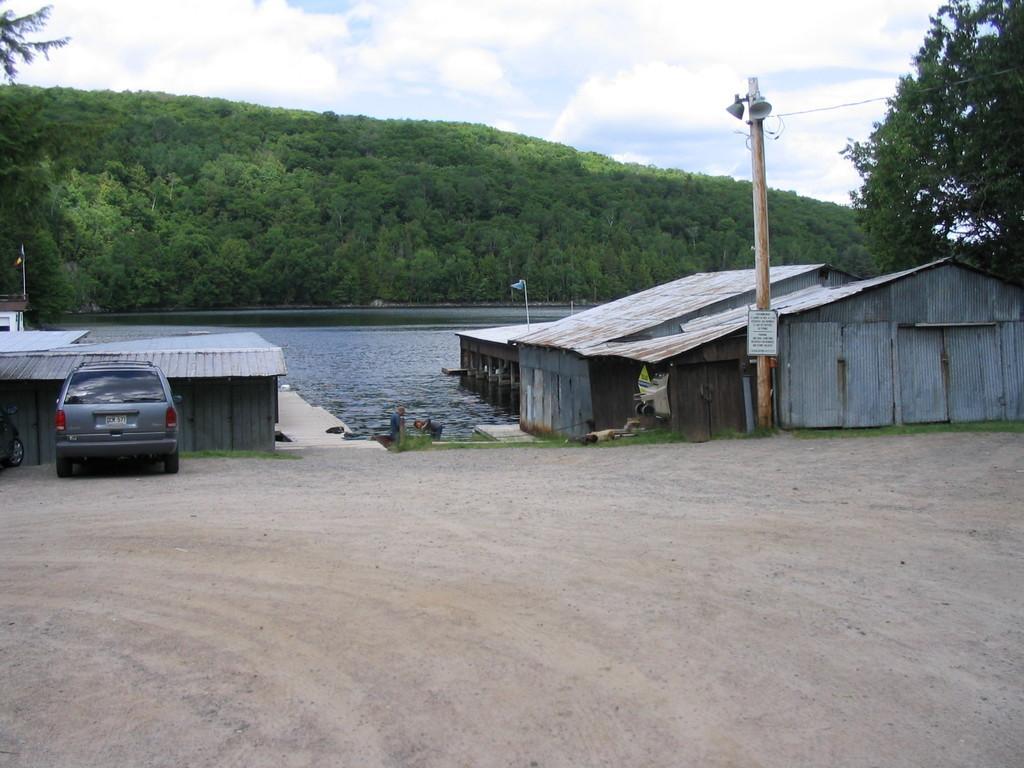In one or two sentences, can you explain what this image depicts? In this picture we can see two cars on the left side, there are sheds, a pole and water in the middle, in the background there are trees, we can see the sky and clouds at the top of the picture. 